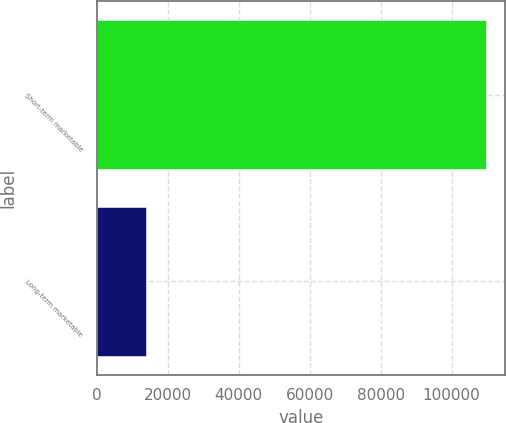<chart> <loc_0><loc_0><loc_500><loc_500><bar_chart><fcel>Short-term marketable<fcel>Long-term marketable<nl><fcel>109557<fcel>13996<nl></chart> 